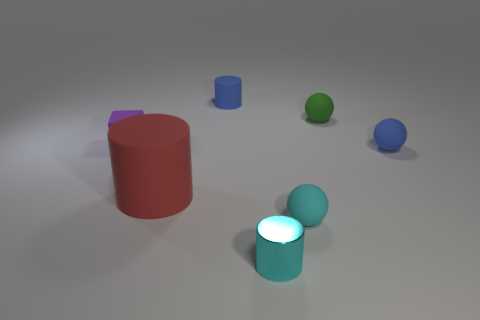Subtract all small cylinders. How many cylinders are left? 1 Subtract all blue spheres. How many spheres are left? 2 Add 2 small blue matte balls. How many objects exist? 9 Subtract all cylinders. How many objects are left? 4 Subtract 1 spheres. How many spheres are left? 2 Subtract 0 brown balls. How many objects are left? 7 Subtract all green spheres. Subtract all blue cylinders. How many spheres are left? 2 Subtract all rubber cubes. Subtract all small rubber spheres. How many objects are left? 3 Add 1 small green objects. How many small green objects are left? 2 Add 5 blue shiny cylinders. How many blue shiny cylinders exist? 5 